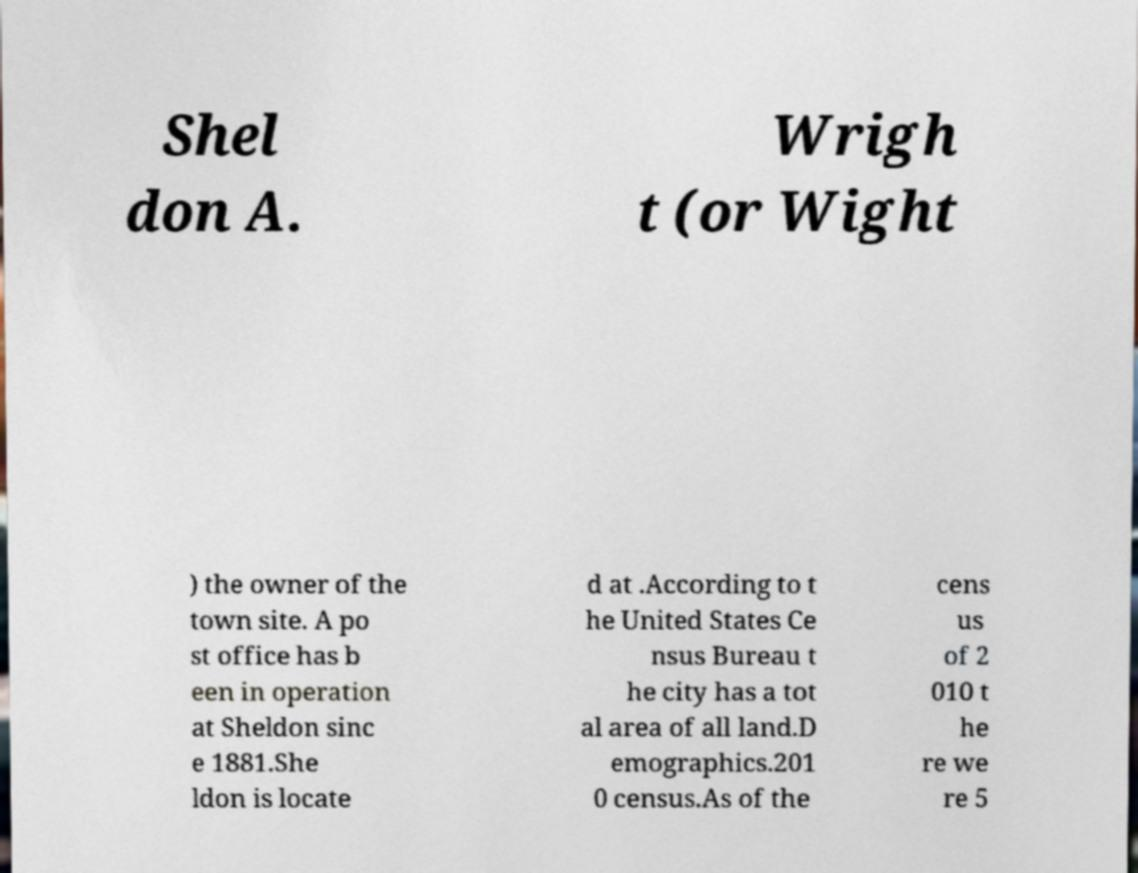Can you read and provide the text displayed in the image?This photo seems to have some interesting text. Can you extract and type it out for me? Shel don A. Wrigh t (or Wight ) the owner of the town site. A po st office has b een in operation at Sheldon sinc e 1881.She ldon is locate d at .According to t he United States Ce nsus Bureau t he city has a tot al area of all land.D emographics.201 0 census.As of the cens us of 2 010 t he re we re 5 